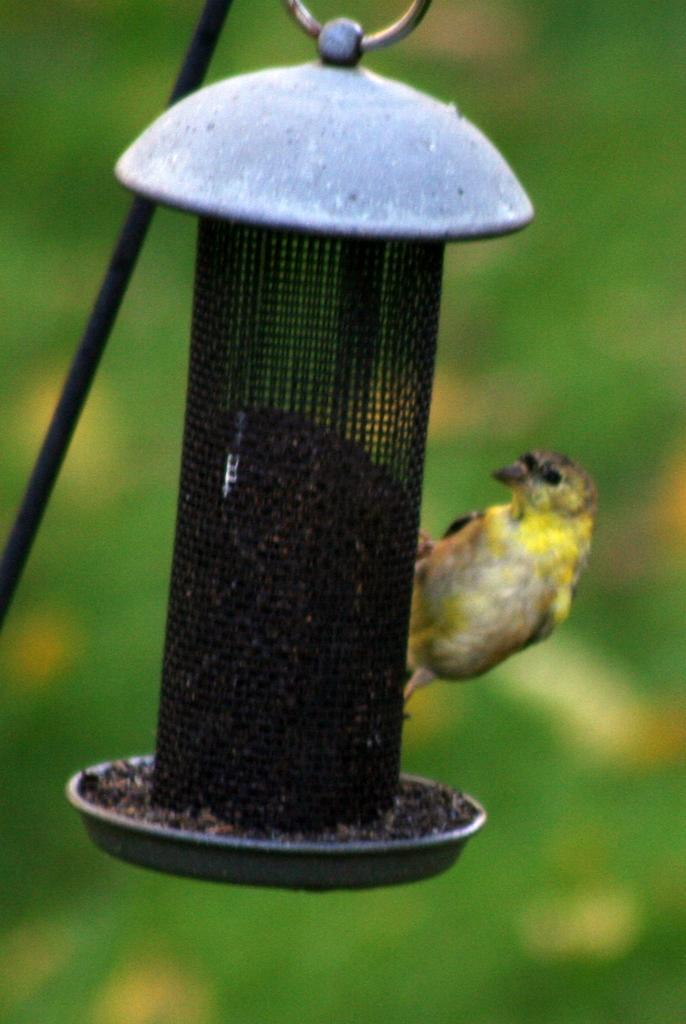Could you give a brief overview of what you see in this image? In this picture we can see an object,rod,bird and in the background we can see trees it is blurry. 